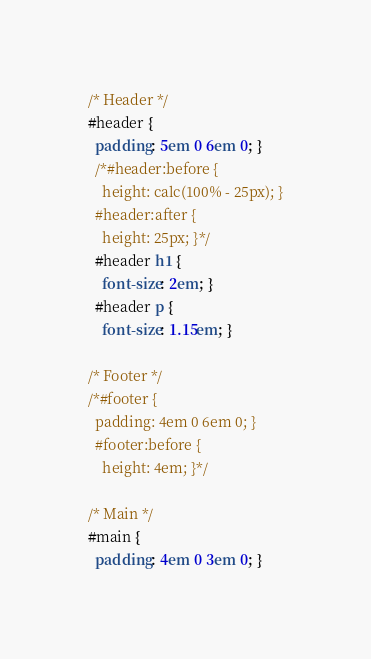<code> <loc_0><loc_0><loc_500><loc_500><_CSS_>
/* Header */
#header {
  padding: 5em 0 6em 0; }
  /*#header:before {
    height: calc(100% - 25px); }
  #header:after {
    height: 25px; }*/
  #header h1 {
    font-size: 2em; }
  #header p {
    font-size: 1.15em; }

/* Footer */
/*#footer {
  padding: 4em 0 6em 0; }
  #footer:before {
    height: 4em; }*/

/* Main */
#main {
  padding: 4em 0 3em 0; }
</code> 